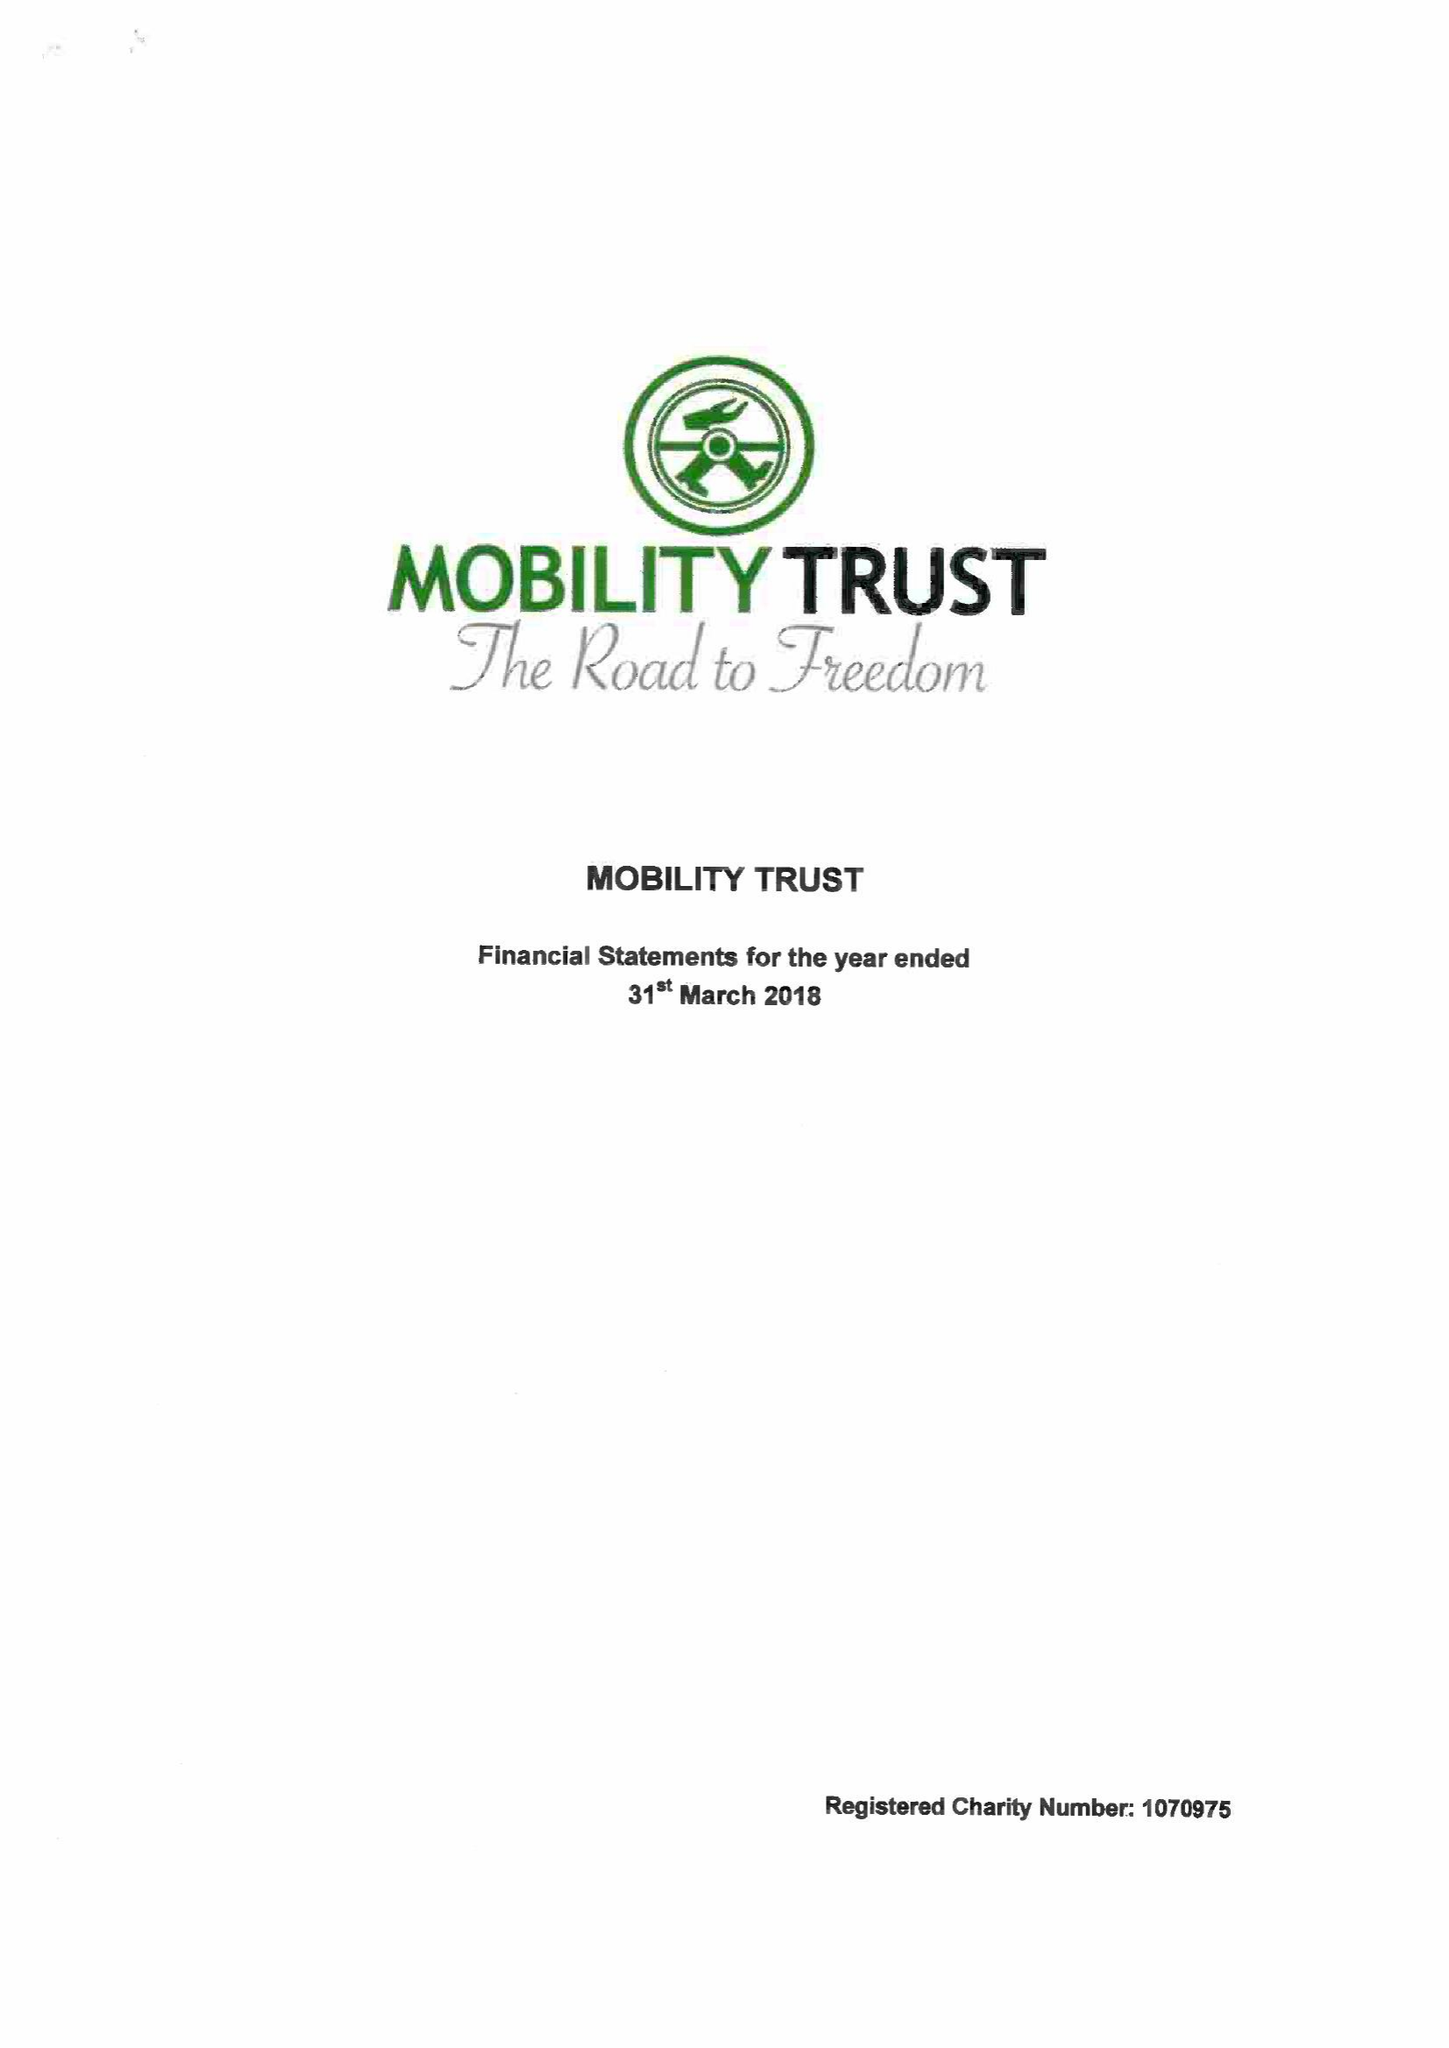What is the value for the address__postcode?
Answer the question using a single word or phrase. RG8 7LR 